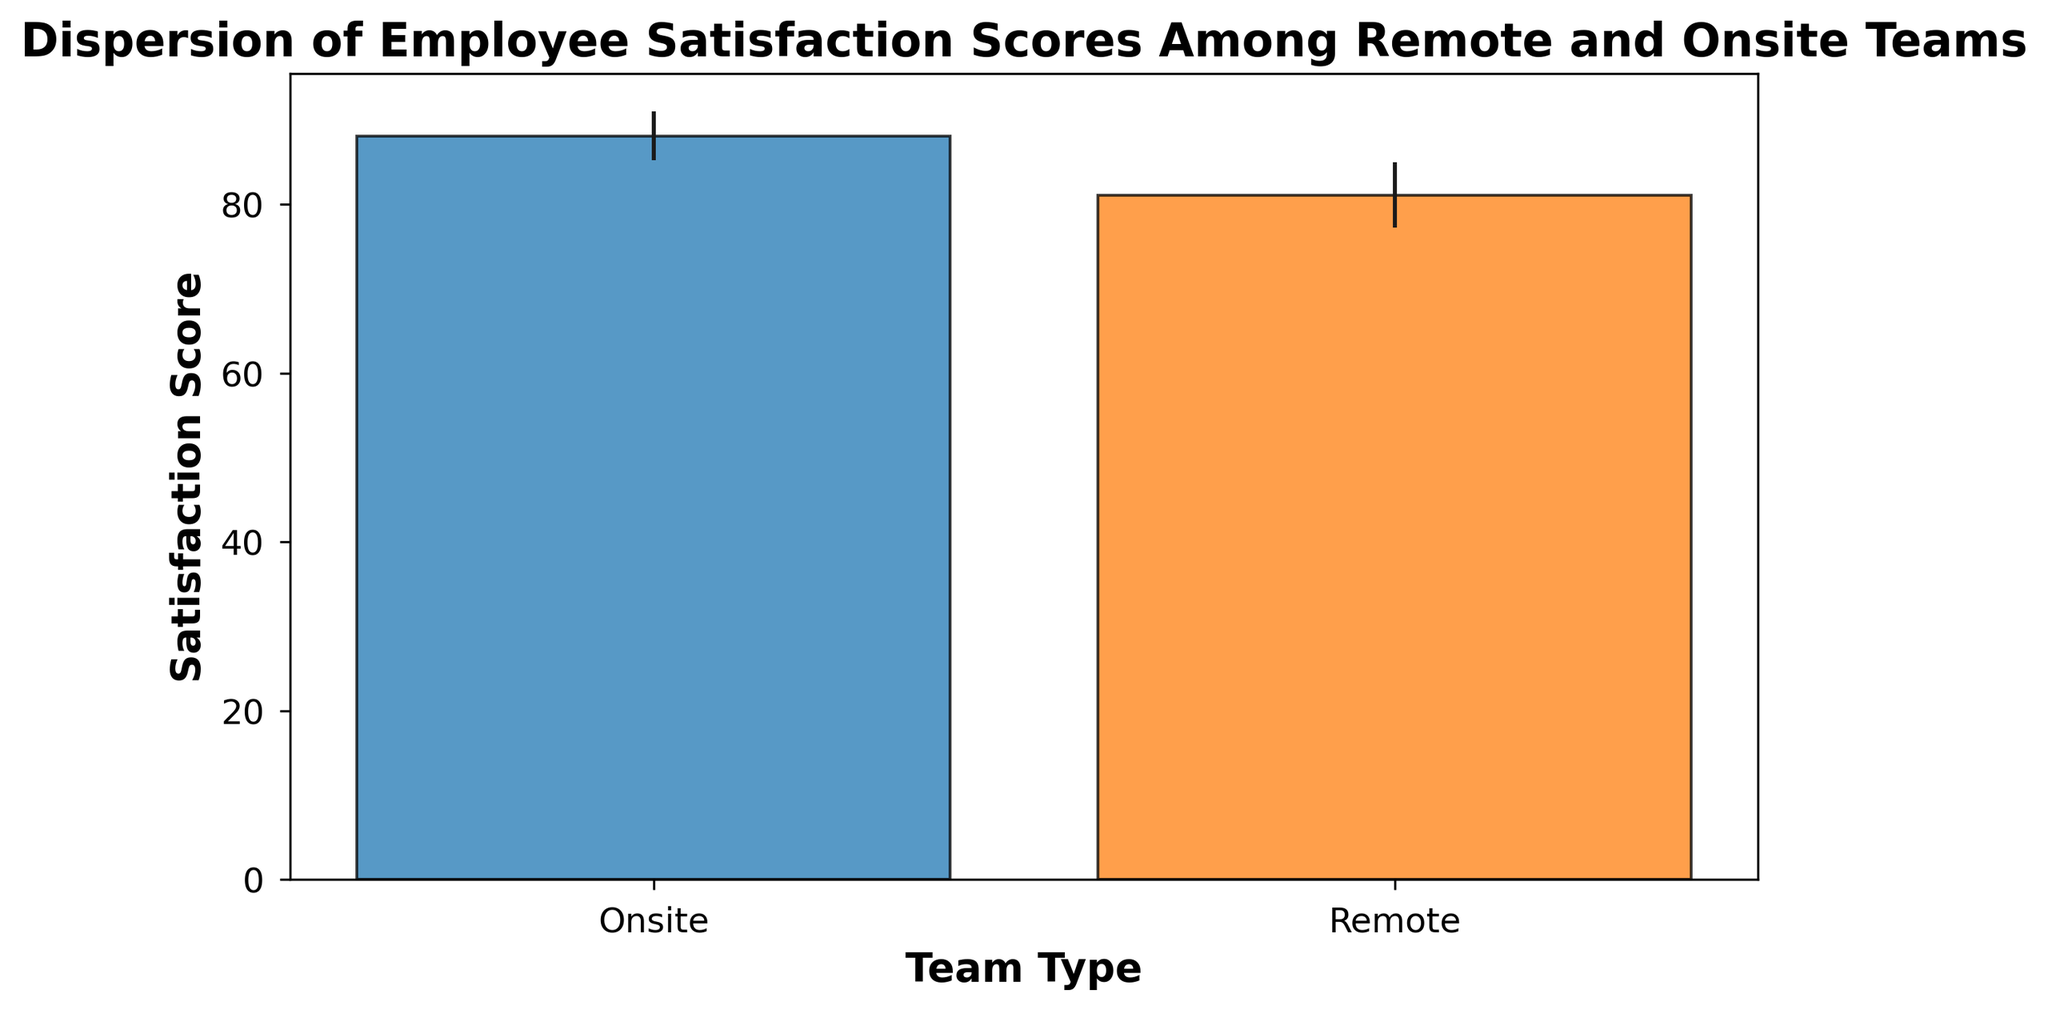What are the mean satisfaction scores for Remote and Onsite teams? The mean satisfaction scores are provided as part of the plotted bar height for each team type. The bar representing the Remote team has its height just above 80, while the bar for the Onsite team is just below 90.
Answer: Remote: around 80, Onsite: around 90 Which team type has a higher mean satisfaction score? By comparing the heights of the bars, the Onsite team’s bar is higher than the Remote team’s bar.
Answer: Onsite What is the dispersion range (standard deviation) for the Remote team’s satisfaction scores? The error bar above and below the Remote team's bar indicates the standard deviation. The value can be approximated from the plot as 4 (given the significant overlap of the error bars with each end around the mean value).
Answer: 4 Which team type has a smaller standard deviation in satisfaction scores? The length of the error bars indicates the standard deviations. The Remote team has shorter error bars compared to the Onsite team, indicating a smaller standard deviation.
Answer: Remote How much higher is the Onsite team's mean satisfaction score compared to the Remote team's? The mean satisfaction score for the Onsite team is around 90, while for the Remote team it is around 80, making the difference approximately 10 points.
Answer: 10 points By how much does the highest satisfaction score observed in the Onsite team differ from the highest satisfaction score observed in the Remote team? This can be calculated using the mean and standard deviation shown in the figure. The Onsite team's highest score is around (mean + std_dev) 90 + 3 = 93, and Remote is 80 + 4 = 84. So, 93 - 84 = 9.
Answer: 9 points What visual differences are there between the bars representing Remote and Onsite teams? The Onsite team's bar is taller, indicating a higher mean satisfaction score. The Onsite team's error bar is longer, indicating a wider dispersion in scores. The colors differ, with the Remote team in blue and the Onsite team in orange.
Answer: Taller bar, longer error bar for the Onsite team, different colors (blue for Remote and orange for Onsite) What are the approximate end values of the error bars for both the Onsite and Remote teams? The error bars span the mean plus or minus the standard deviation. For the Onsite team, this is approximately 87 (90 - 3) to 93 (90 + 3), and for the Remote team, it is approximately 76 (80 - 4) to 84 (80 + 4).
Answer: Onsite: 87 to 93, Remote: 76 to 84 